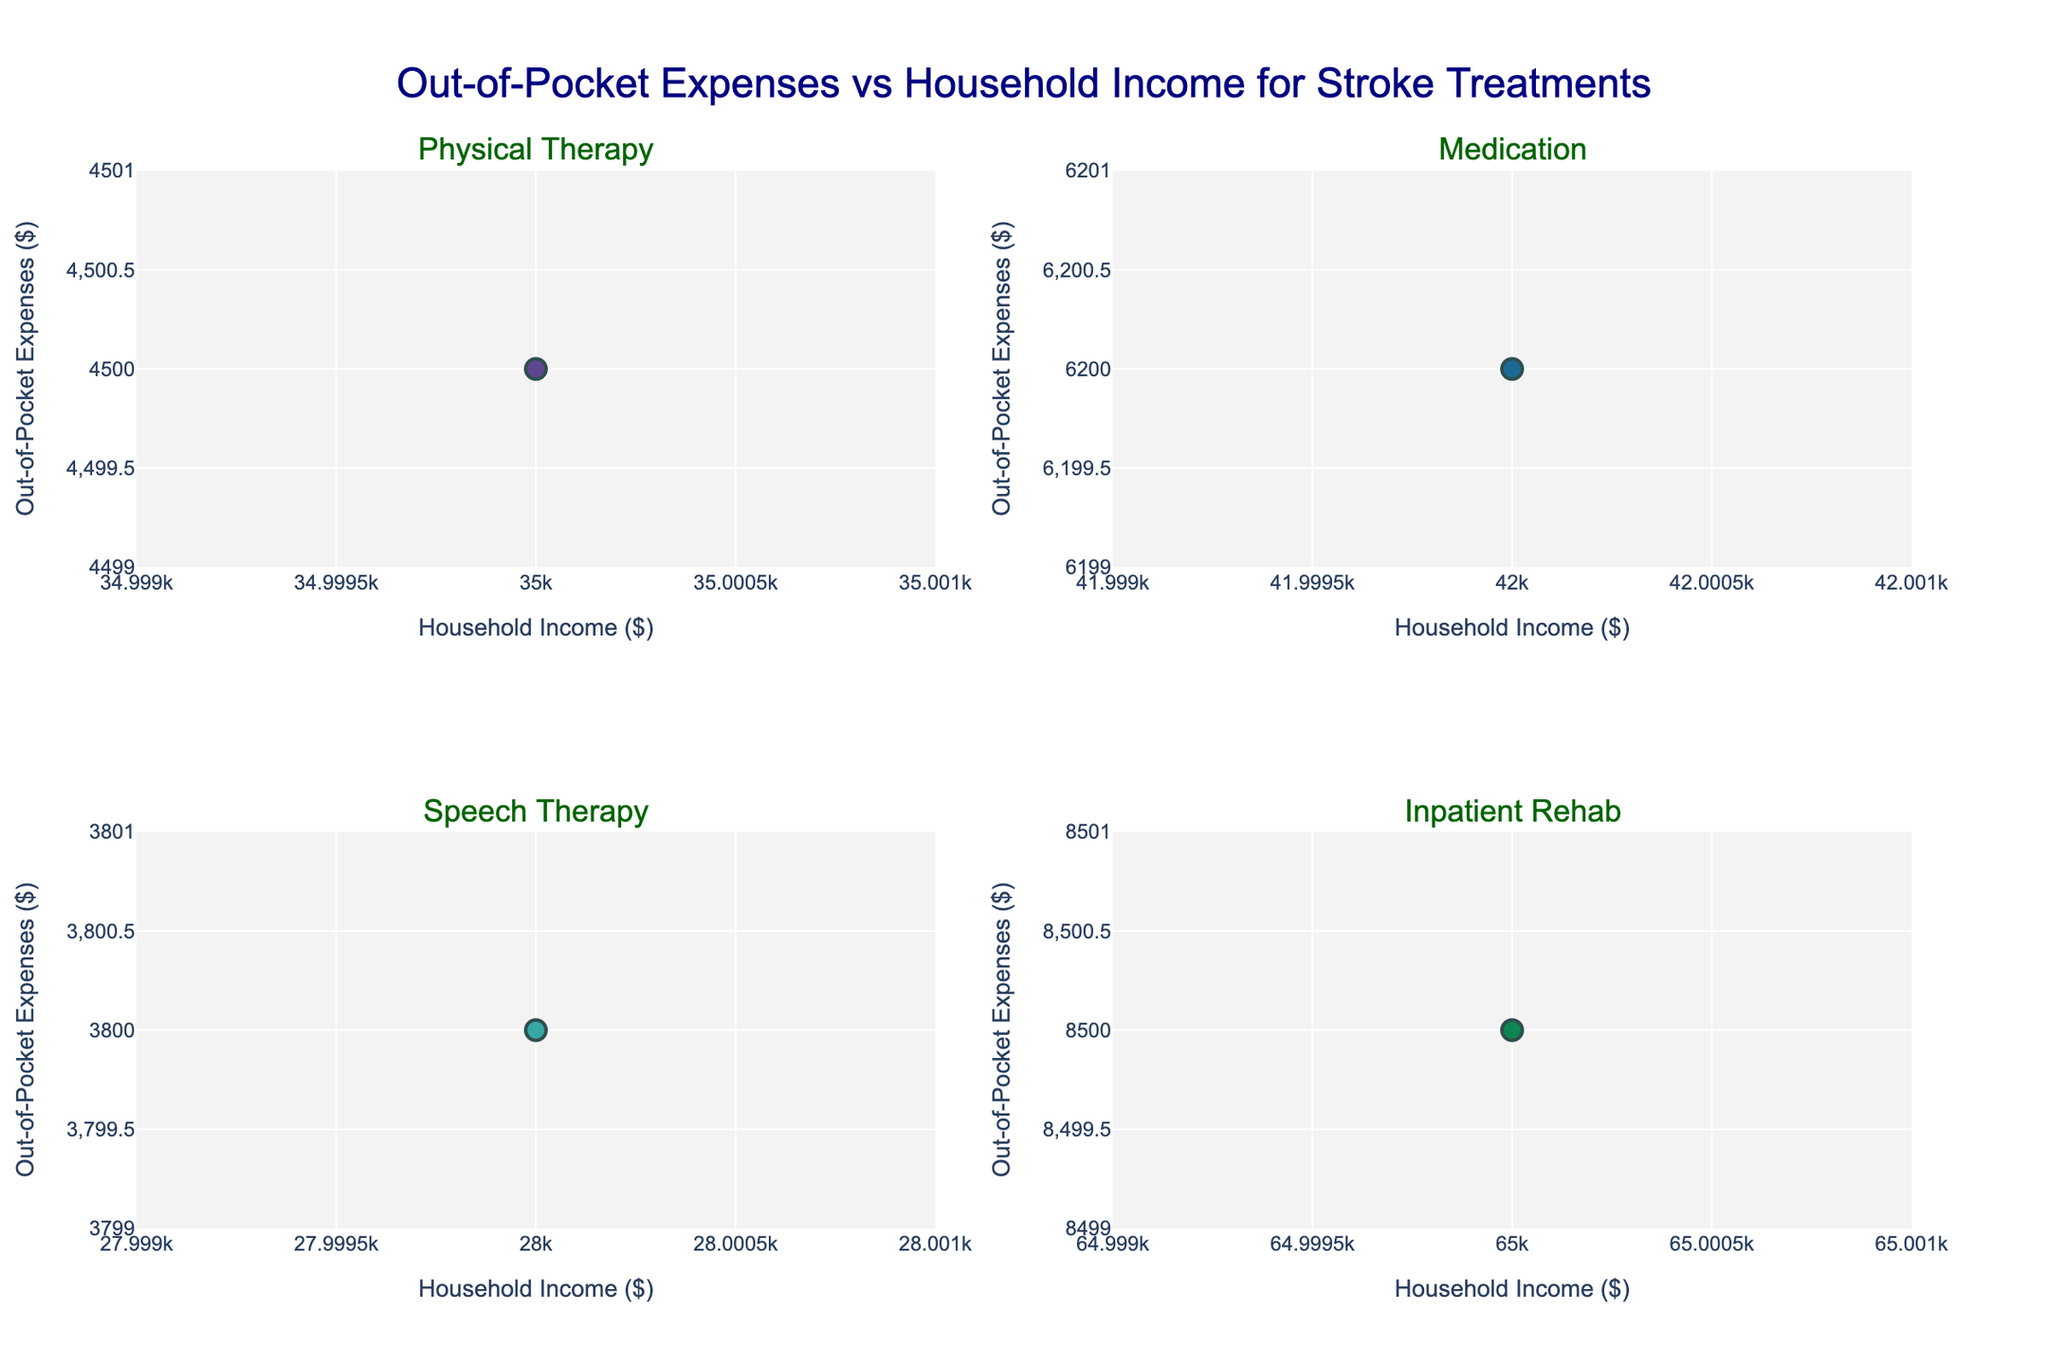What is the main title of the figure? The main title of the figure appears at the top and summarizes the content shown in the plots. By looking at the top-center of the figure, we can read "Out-of-Pocket Expenses vs Household Income for Stroke Treatments".
Answer: Out-of-Pocket Expenses vs Household Income for Stroke Treatments How many scatter plots are included in the figure? The figure is composed of multiple subplots arranged within the main plot. By counting the scatter plots, we can see there are four individual scatter plots.
Answer: Four Which region has the highest out-of-pocket expense for Physical Therapy? To determine this, we look at the scatter plot labeled "Physical Therapy" and find the data point with the highest y-value, representing the highest out-of-pocket expense, and then check the associated region from the hover information.
Answer: Midwest Which treatment type shows an out-of-pocket expense of $6,800 for a household income of $45,000? To answer this, we examine each subplot to find the data point where the x-value (household income) is $45,000 and the y-value (out-of-pocket expense) is $6,800. Based on the points plotted, this entry appears under "Nursing Care".
Answer: Nursing Care What is the out-of-pocket expense for Medication in the Northeast region? We locate the scatter plot for "Medication" and identify the data point that represents the Northeast region, then read its y-value for out-of-pocket expense.
Answer: $6,200 How does the trend of out-of-pocket expenses for Inpatient Rehab compare to those of Physical Therapy? Comparing trends involves looking at the relative positions and spreads of data points in the scatter plots for each treatment type. Inpatient Rehab shows points clustered at higher income levels and higher expenses compared to Physical Therapy, which clusters lower.
Answer: Inpatient Rehab generally has higher expenses and income levels In the plots, which scatter plot seems to have the highest concentration of low income versus high expenses? By observing the scatter plots and comparing the density of lower x-values (income) paired with higher y-values (expenses), "Inpatient Rehab" notably shows higher expenses even for relatively higher incomes, indicating a tendency for higher out-of-pocket costs.
Answer: Inpatient Rehab What are the x and y-axis labels for the scatter plot of Speech Therapy? The labels of axes describe the variables plotted. By looking at the specific subplot for "Speech Therapy", we can note the x-axis is labeled "Household Income ($)" and the y-axis is "Out-of-Pocket Expenses ($)".
Answer: Household Income ($) and Out-of-Pocket Expenses ($) Which scatter plot indicates the highest variability in out-of-pocket expenses for similar household incomes? Variability is judged by the spread of data points along the y-axis for a given range of x-axis values. Observing the scatter plots, the "Medication" scatter plot shows the highest variability for similar incomes.
Answer: Medication 